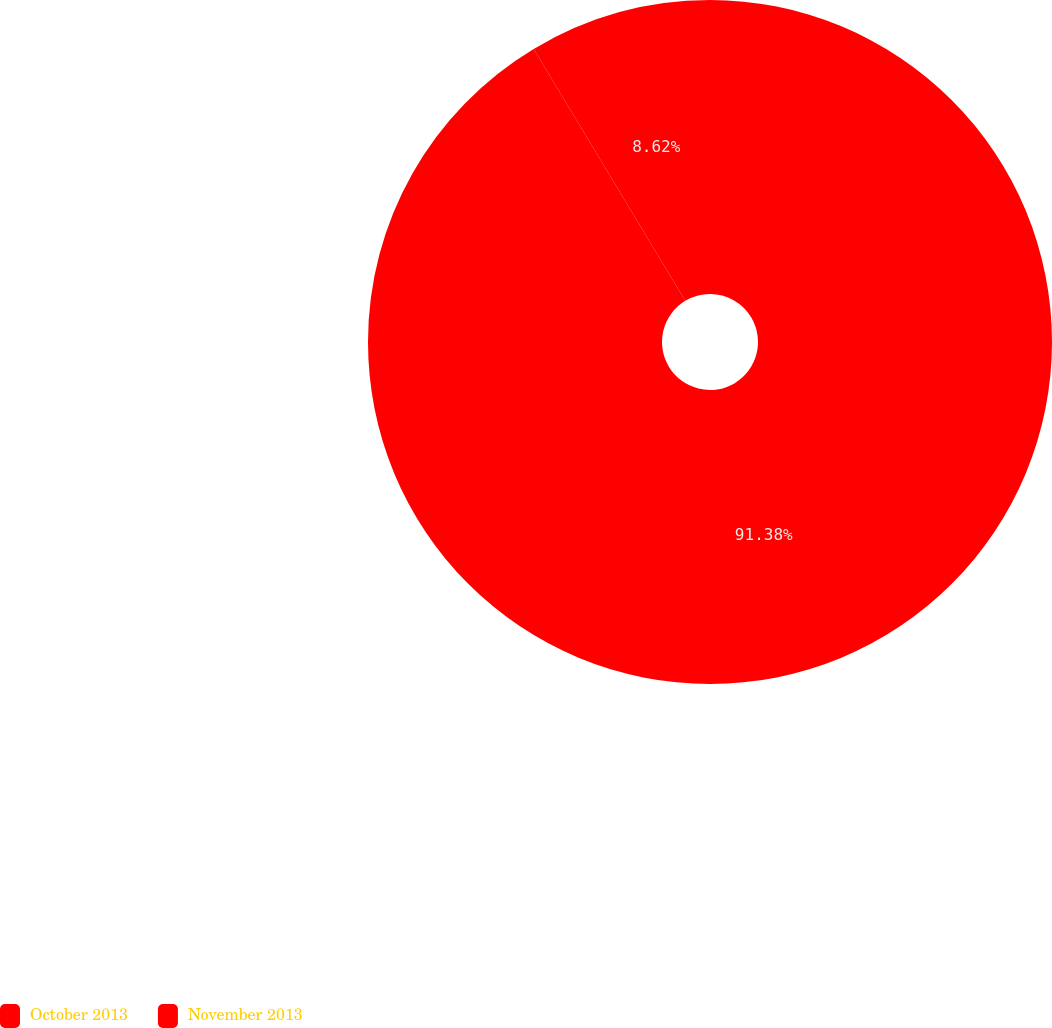<chart> <loc_0><loc_0><loc_500><loc_500><pie_chart><fcel>October 2013<fcel>November 2013<nl><fcel>91.38%<fcel>8.62%<nl></chart> 